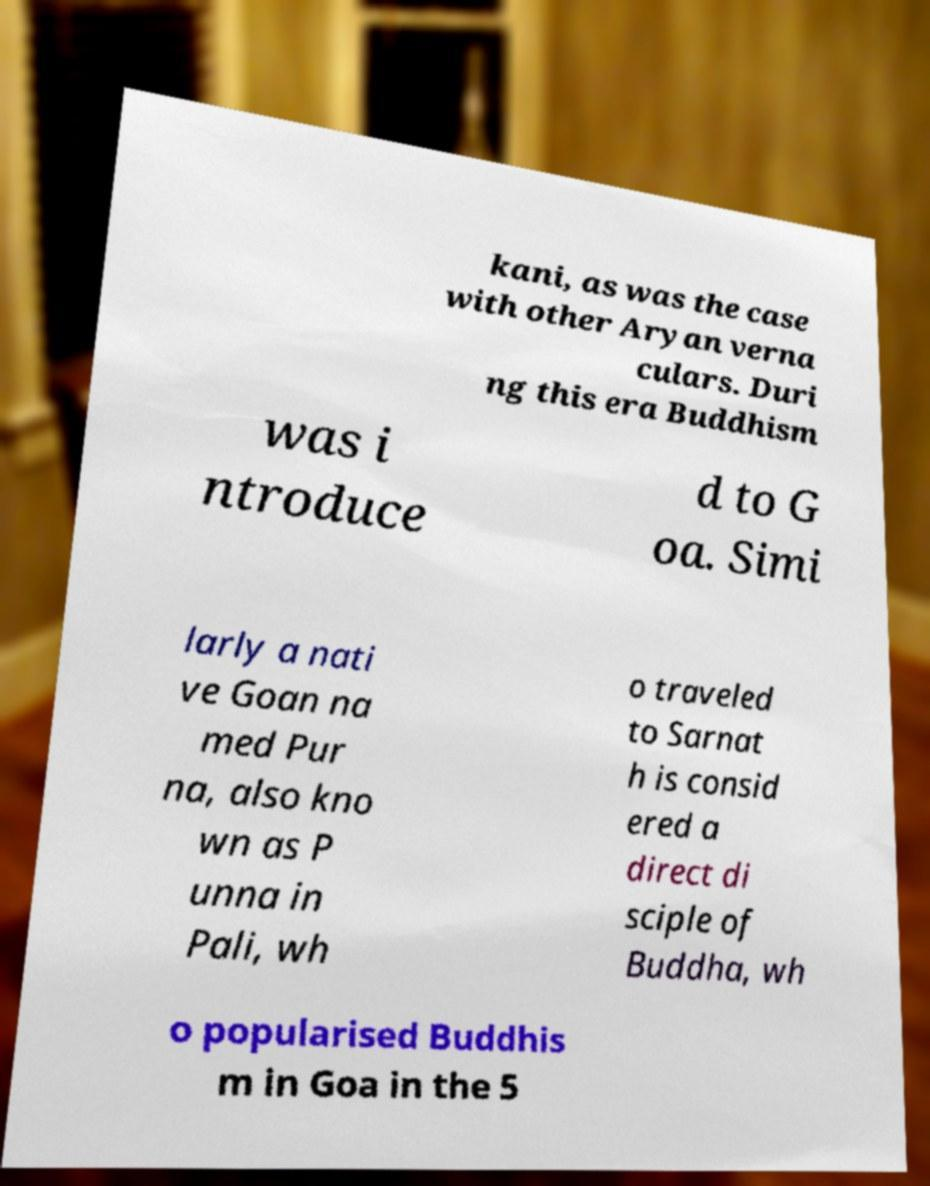I need the written content from this picture converted into text. Can you do that? kani, as was the case with other Aryan verna culars. Duri ng this era Buddhism was i ntroduce d to G oa. Simi larly a nati ve Goan na med Pur na, also kno wn as P unna in Pali, wh o traveled to Sarnat h is consid ered a direct di sciple of Buddha, wh o popularised Buddhis m in Goa in the 5 